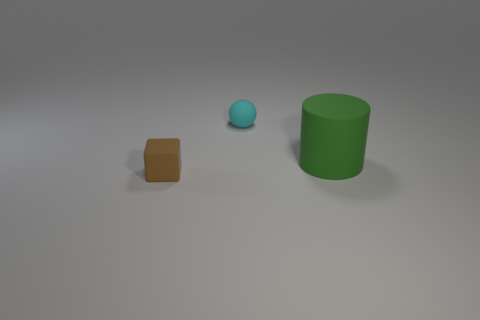Is there anything else that has the same size as the green cylinder?
Your response must be concise. No. Does the cyan ball have the same size as the green cylinder?
Offer a terse response. No. There is a small ball; are there any tiny brown matte cubes in front of it?
Offer a terse response. Yes. How big is the rubber object that is both behind the small brown rubber object and in front of the small cyan rubber ball?
Give a very brief answer. Large. How many things are small spheres or large green things?
Make the answer very short. 2. There is a matte block; is its size the same as the cyan rubber ball left of the green cylinder?
Your answer should be very brief. Yes. How big is the brown rubber cube that is in front of the small matte thing on the right side of the small object that is in front of the small cyan rubber thing?
Provide a succinct answer. Small. Are there any tiny cyan metal blocks?
Give a very brief answer. No. What number of objects are small rubber objects in front of the rubber sphere or balls that are behind the big green rubber cylinder?
Give a very brief answer. 2. What number of big green cylinders are in front of the small rubber object to the right of the small brown thing?
Offer a very short reply. 1. 